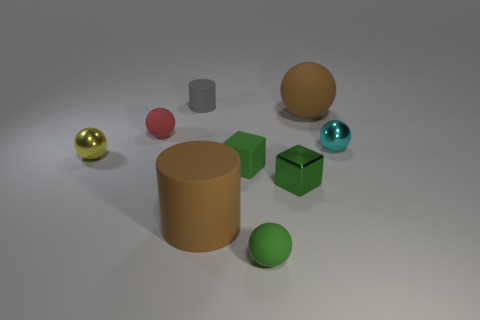What shape is the tiny metal thing that is the same color as the small rubber block?
Your response must be concise. Cube. The red rubber thing that is the same size as the gray object is what shape?
Offer a very short reply. Sphere. What number of things are green cubes or red rubber objects?
Your response must be concise. 3. Are there any small green metallic objects?
Give a very brief answer. Yes. Are there fewer shiny cubes than tiny yellow metal cylinders?
Your answer should be compact. No. Are there any red spheres of the same size as the cyan sphere?
Offer a terse response. Yes. There is a tiny cyan metal object; is it the same shape as the metallic object that is in front of the yellow metallic ball?
Offer a terse response. No. How many blocks are green things or cyan metallic objects?
Ensure brevity in your answer.  2. The small matte cylinder has what color?
Give a very brief answer. Gray. Is the number of cyan balls greater than the number of shiny objects?
Provide a short and direct response. No. 